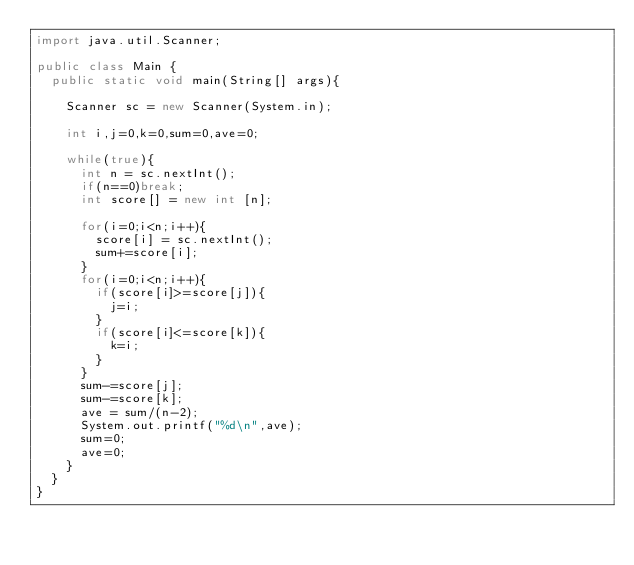Convert code to text. <code><loc_0><loc_0><loc_500><loc_500><_Java_>import java.util.Scanner;

public class Main {
	public static void main(String[] args){

		Scanner sc = new Scanner(System.in);

		int i,j=0,k=0,sum=0,ave=0;

		while(true){
			int n = sc.nextInt();
			if(n==0)break;
			int score[] = new int [n];

			for(i=0;i<n;i++){
				score[i] = sc.nextInt();
				sum+=score[i];
			}
			for(i=0;i<n;i++){
				if(score[i]>=score[j]){
					j=i;
				}
				if(score[i]<=score[k]){
					k=i;
				}
			}
			sum-=score[j];
			sum-=score[k];
			ave = sum/(n-2);
			System.out.printf("%d\n",ave);
			sum=0;
			ave=0;
		}
	}
}</code> 